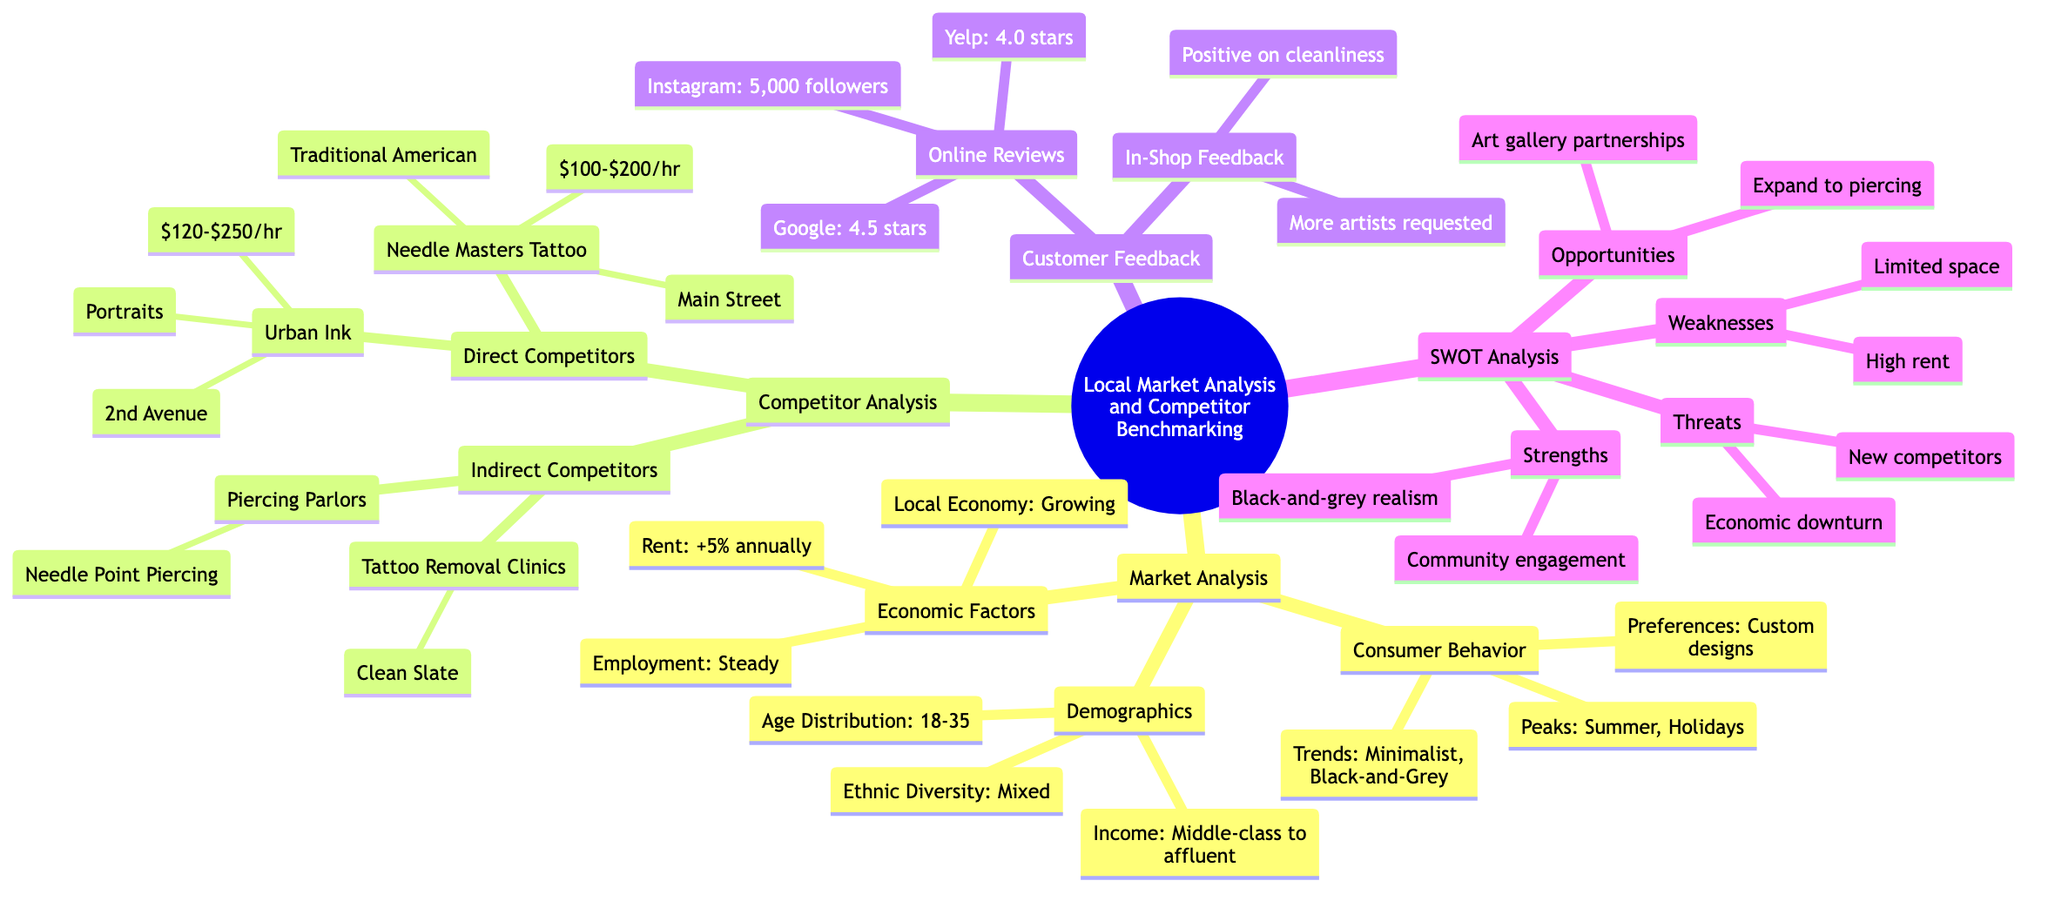What is the income level of the local market? The diagram states that the income levels are categorized as "Middle-class to affluent." This is found under the "Demographics" section of the "Market Analysis."
Answer: Middle-class to affluent How many direct competitors are listed? According to the "Competitor Analysis" section, there are two direct competitors: "Needle Masters Tattoo" and "Urban Ink." Therefore, when counting these, the answer comes out to two.
Answer: 2 What specialty does Urban Ink focus on? The diagram specifies that Urban Ink specializes in "Portraits, Custom Designs" under the "Direct Competitors" section. This is a clear descriptor associated with that competitor.
Answer: Portraits, Custom Designs What is the average price range for Needle Masters Tattoo? The price range for Needle Masters Tattoo is stated as "$100-$200 per hour" in the "Direct Competitors" section. This gives a clear range for their pricing strategy.
Answer: $100-$200 per hour Which economic factor is affecting rent prices? Under "Economic Factors," it mentions that rent prices are "Increasing by 5% annually." This outlines the specific concern related to rent within the local economy.
Answer: Increasing by 5% annually List one opportunity identified in the SWOT Analysis. In the "Opportunities" section of the SWOT Analysis, one of the opportunities identified is "Offering piercing services." This indicates a potential area for expansion for the tattoo shop.
Answer: Offering piercing services What is the average star rating on Google Reviews? The "Online Reviews" section indicates that the Google Reviews rating is "4.5 stars from 200 reviews." This gives a specific quantitative measure of online feedback.
Answer: 4.5 stars What is a request noted in the In-Shop Feedback? The "In-Shop Feedback" mentions that there are "Common requests for more artists." This implies customer feedback regarding staffing needs.
Answer: More artists requested What is a major threat mentioned in the SWOT Analysis? The SWOT Analysis points to "New Competitors" as a significant threat. This reflects the competitive landscape issue affecting the tattoo shop.
Answer: New Competitors 